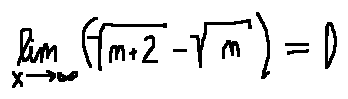Convert formula to latex. <formula><loc_0><loc_0><loc_500><loc_500>\lim \lim i t s _ { x \rightarrow \infty } ( \sqrt { n + 2 } - \sqrt { n } ) = 0</formula> 